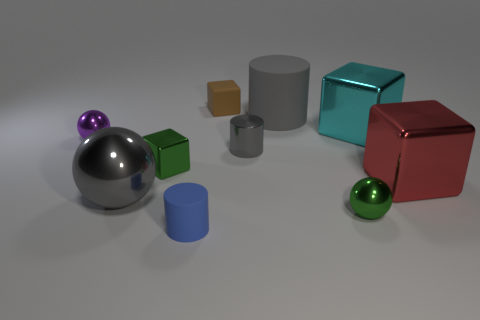Is the number of tiny rubber cubes less than the number of tiny objects?
Your answer should be very brief. Yes. Are there any large spheres that have the same color as the large matte thing?
Make the answer very short. Yes. There is a small object that is to the right of the small rubber cube and in front of the big red shiny block; what shape is it?
Your answer should be compact. Sphere. What is the shape of the small matte thing behind the small green metal object that is on the right side of the matte cube?
Make the answer very short. Cube. Does the purple metallic thing have the same shape as the big gray shiny thing?
Provide a short and direct response. Yes. There is another cylinder that is the same color as the tiny metallic cylinder; what material is it?
Offer a terse response. Rubber. Does the large rubber thing have the same color as the metallic cylinder?
Ensure brevity in your answer.  Yes. There is a tiny cube that is behind the green object left of the tiny brown block; how many green metal objects are on the right side of it?
Make the answer very short. 1. The green thing that is the same material as the small green sphere is what shape?
Ensure brevity in your answer.  Cube. What material is the cylinder that is in front of the gray metal thing that is right of the small cube in front of the tiny brown cube?
Offer a terse response. Rubber. 